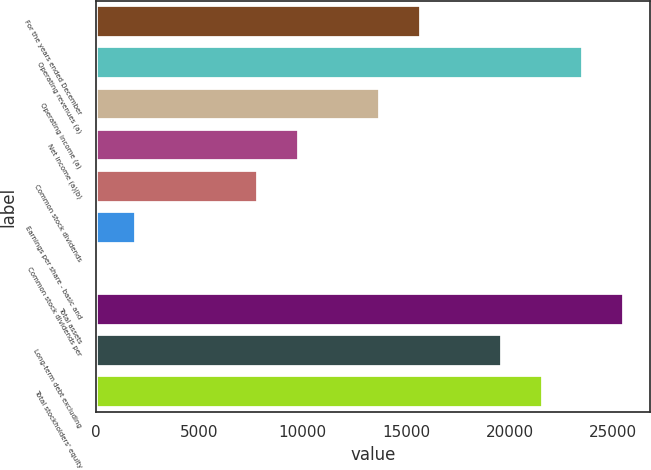Convert chart to OTSL. <chart><loc_0><loc_0><loc_500><loc_500><bar_chart><fcel>For the years ended December<fcel>Operating revenues (a)<fcel>Operating income (a)<fcel>Net income (a)(b)<fcel>Common stock dividends<fcel>Earnings per share - basic and<fcel>Common stock dividends per<fcel>Total assets<fcel>Long-term debt excluding<fcel>Total stockholders' equity<nl><fcel>15708.5<fcel>23561.5<fcel>13745.3<fcel>9818.79<fcel>7855.54<fcel>1965.79<fcel>2.54<fcel>25524.8<fcel>19635<fcel>21598.3<nl></chart> 